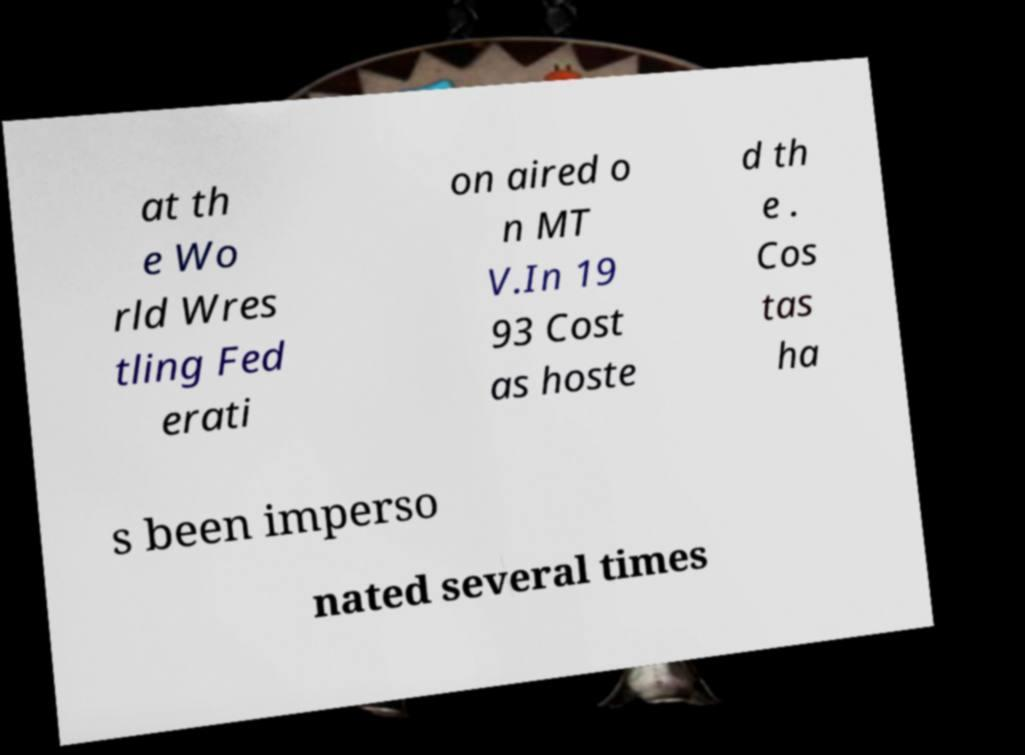Could you extract and type out the text from this image? at th e Wo rld Wres tling Fed erati on aired o n MT V.In 19 93 Cost as hoste d th e . Cos tas ha s been imperso nated several times 